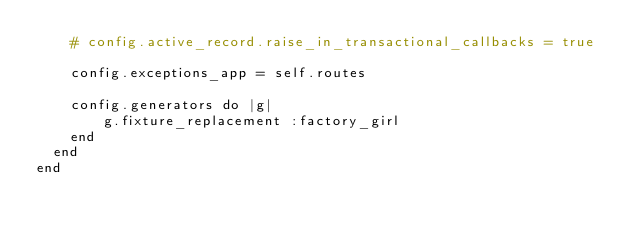<code> <loc_0><loc_0><loc_500><loc_500><_Ruby_>    # config.active_record.raise_in_transactional_callbacks = true

    config.exceptions_app = self.routes

    config.generators do |g|
        g.fixture_replacement :factory_girl
    end
  end
end
</code> 